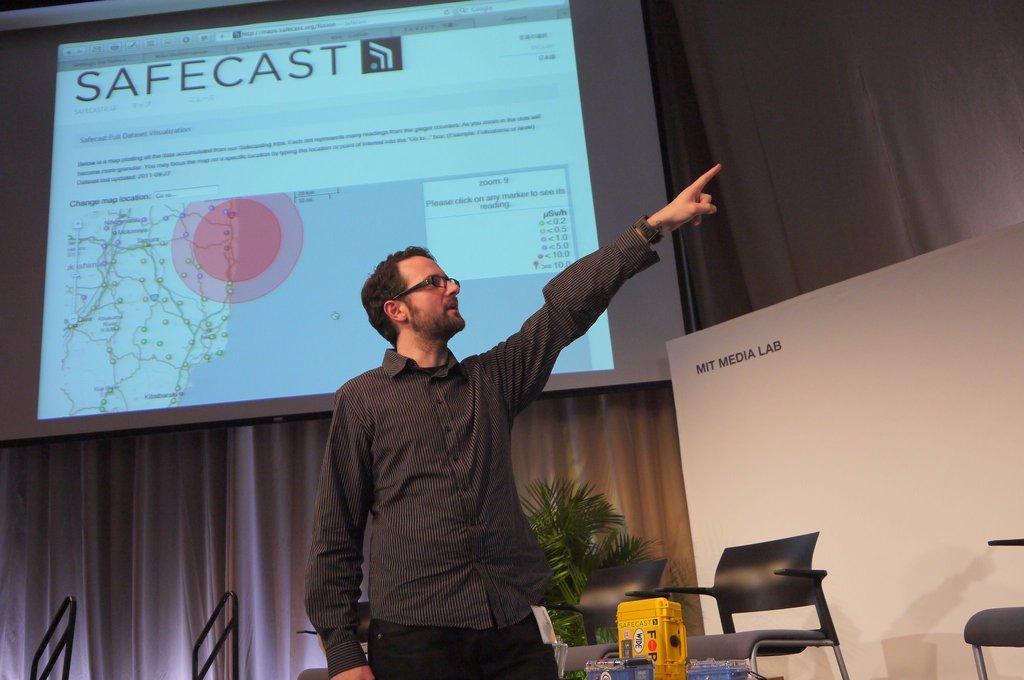In one or two sentences, can you explain what this image depicts? A man is standing and pointing his hands towards left side behind him there is a projected image. 